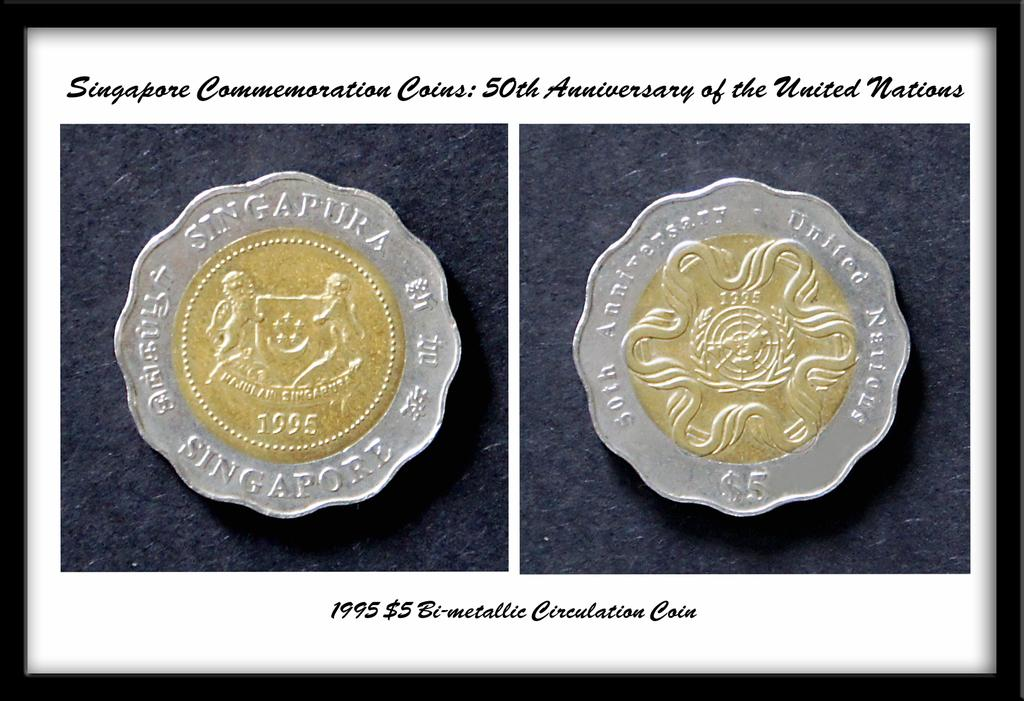<image>
Describe the image concisely. coins for Singapore Commemoration 50th Anniversary of the United Nations 